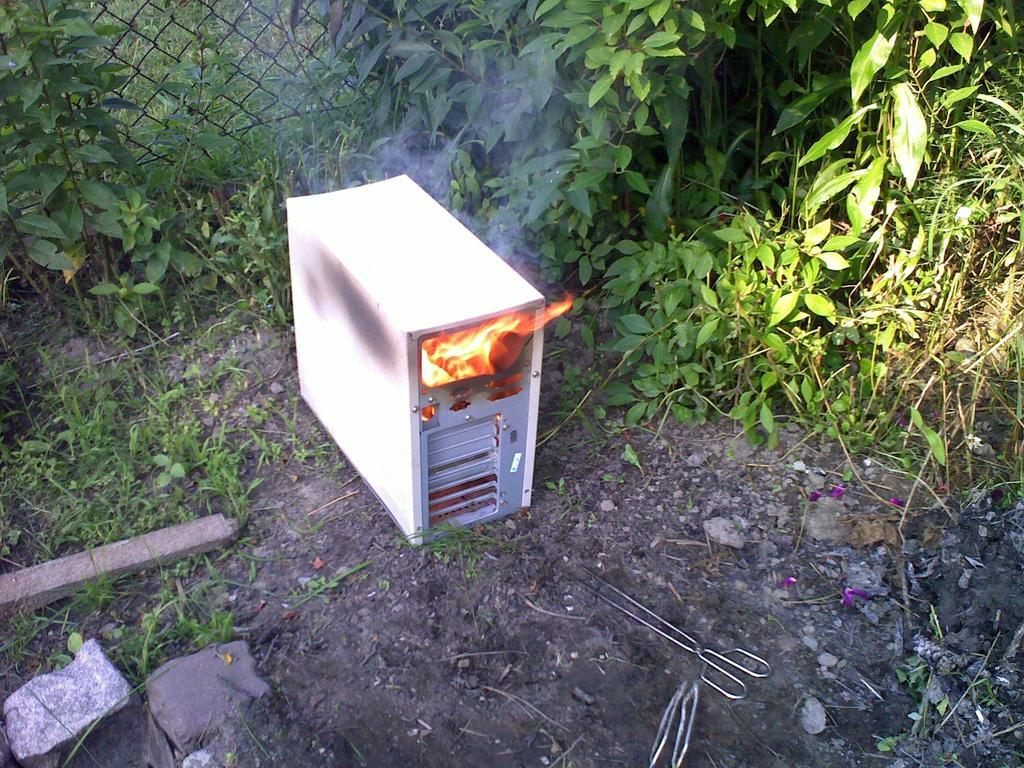What type of living organisms can be seen in the image? Plants can be seen in the image. What material is the fence in the image made of? The fence in the image is made of metal. Is there any fire visible in the image? Yes, there is fire in the CPU. What objects can be found on the ground in the image? Scissors are on the ground in the image. What type of natural elements are present in the image? Stones are present in the image. Can you describe the home in the image? There is no home present in the image. What type of sidewalk can be seen in the image? There is no sidewalk present in the image. 